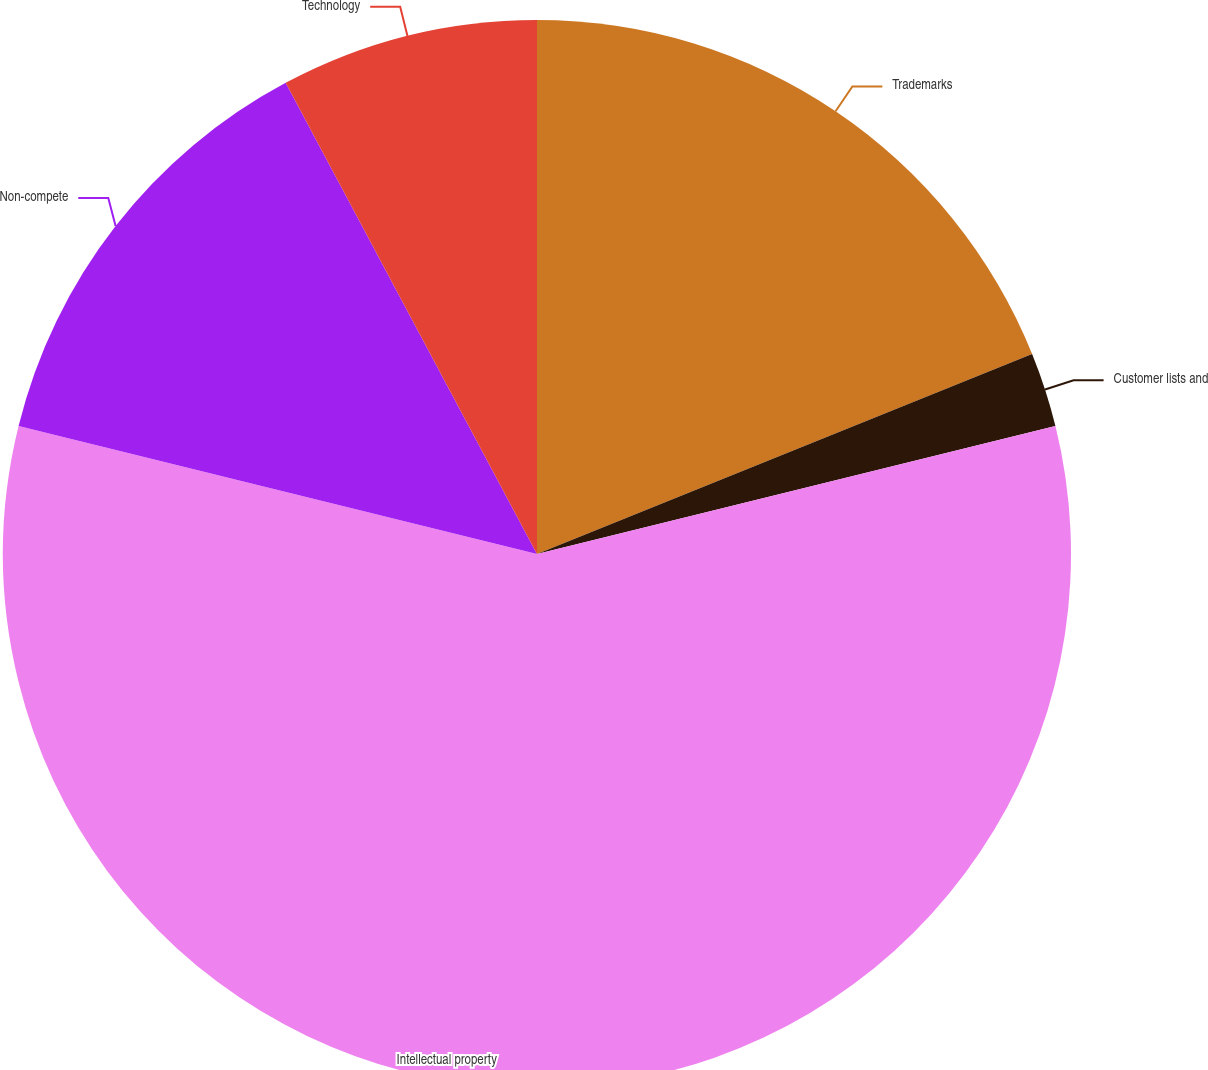Convert chart. <chart><loc_0><loc_0><loc_500><loc_500><pie_chart><fcel>Trademarks<fcel>Customer lists and<fcel>Intellectual property<fcel>Non-compete<fcel>Technology<nl><fcel>18.89%<fcel>2.26%<fcel>57.71%<fcel>13.35%<fcel>7.8%<nl></chart> 